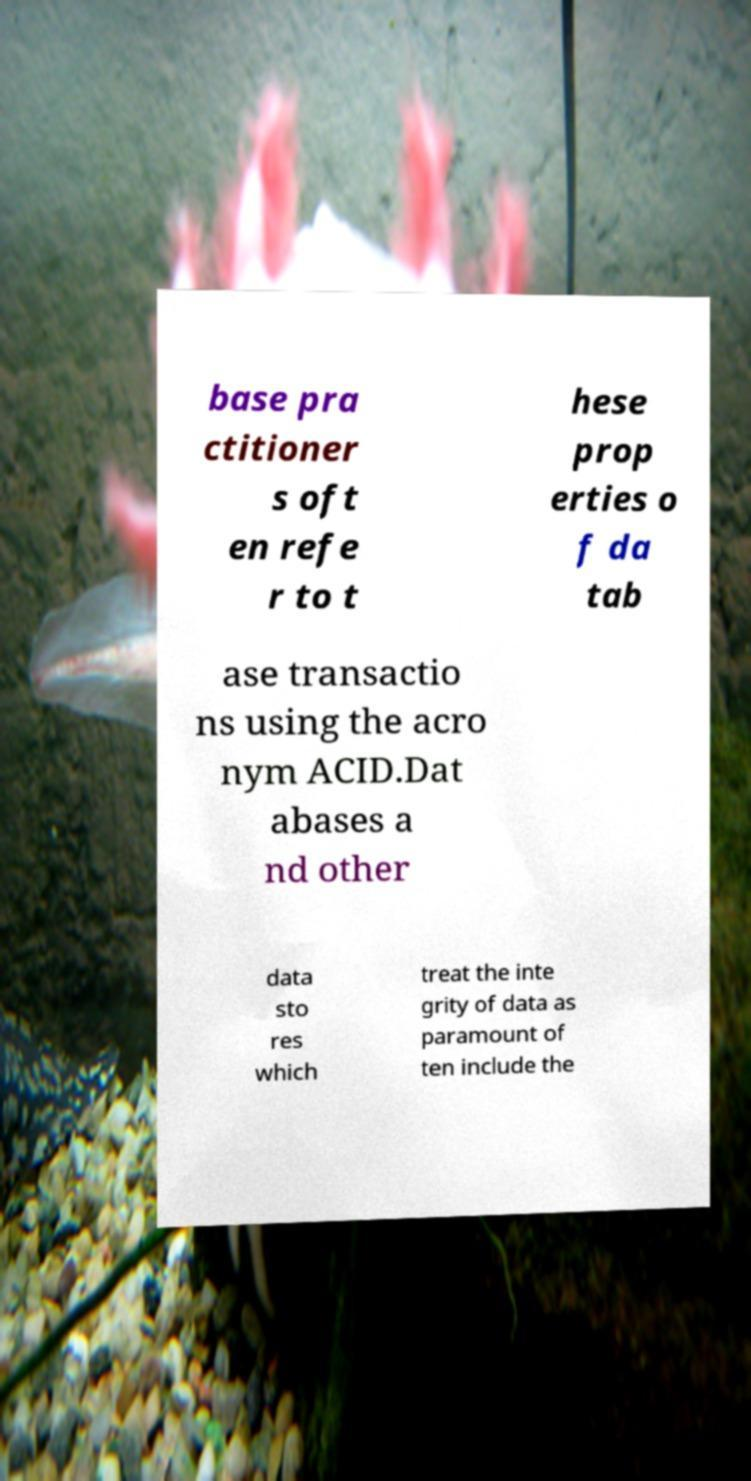I need the written content from this picture converted into text. Can you do that? base pra ctitioner s oft en refe r to t hese prop erties o f da tab ase transactio ns using the acro nym ACID.Dat abases a nd other data sto res which treat the inte grity of data as paramount of ten include the 